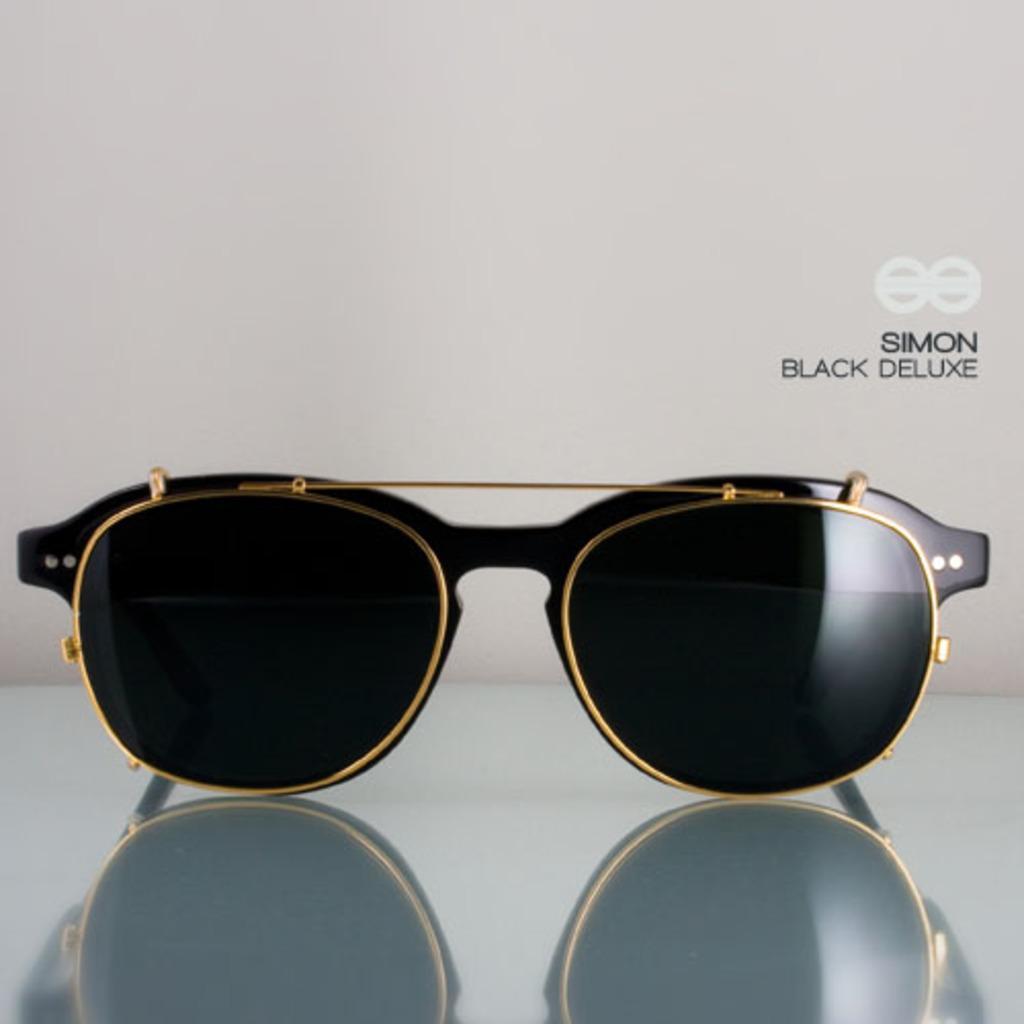Could you give a brief overview of what you see in this image? In this picture we can see the black sunglasses placed on the glass table. Behind there is a white background. On the right side of the image we can see the small water mark. 